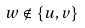<formula> <loc_0><loc_0><loc_500><loc_500>w \notin \{ u , v \}</formula> 